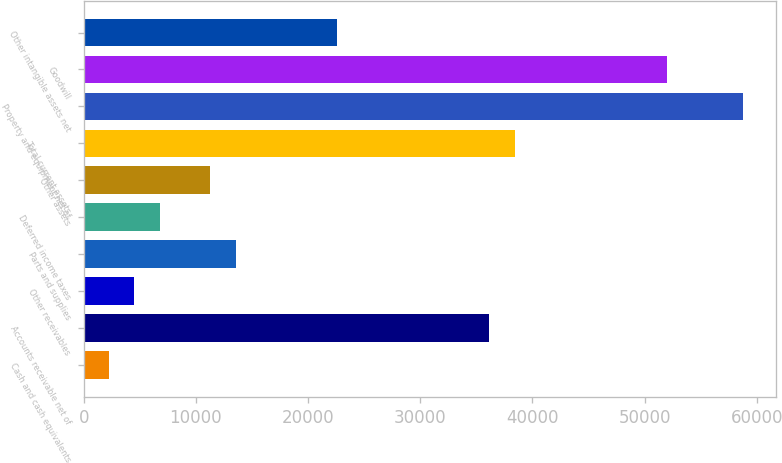<chart> <loc_0><loc_0><loc_500><loc_500><bar_chart><fcel>Cash and cash equivalents<fcel>Accounts receivable net of<fcel>Other receivables<fcel>Parts and supplies<fcel>Deferred income taxes<fcel>Other assets<fcel>Total current assets<fcel>Property and equipment net of<fcel>Goodwill<fcel>Other intangible assets net<nl><fcel>2265.7<fcel>36161.2<fcel>4525.4<fcel>13564.2<fcel>6785.1<fcel>11304.5<fcel>38420.9<fcel>58758.2<fcel>51979.1<fcel>22603<nl></chart> 